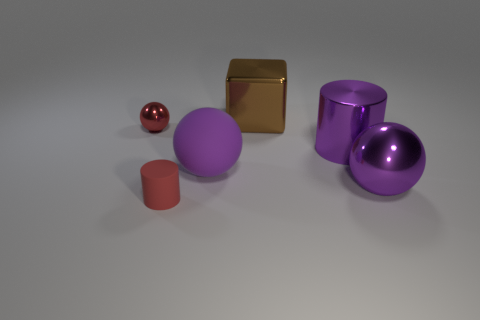There is a metallic cylinder that is the same size as the matte ball; what color is it? purple 